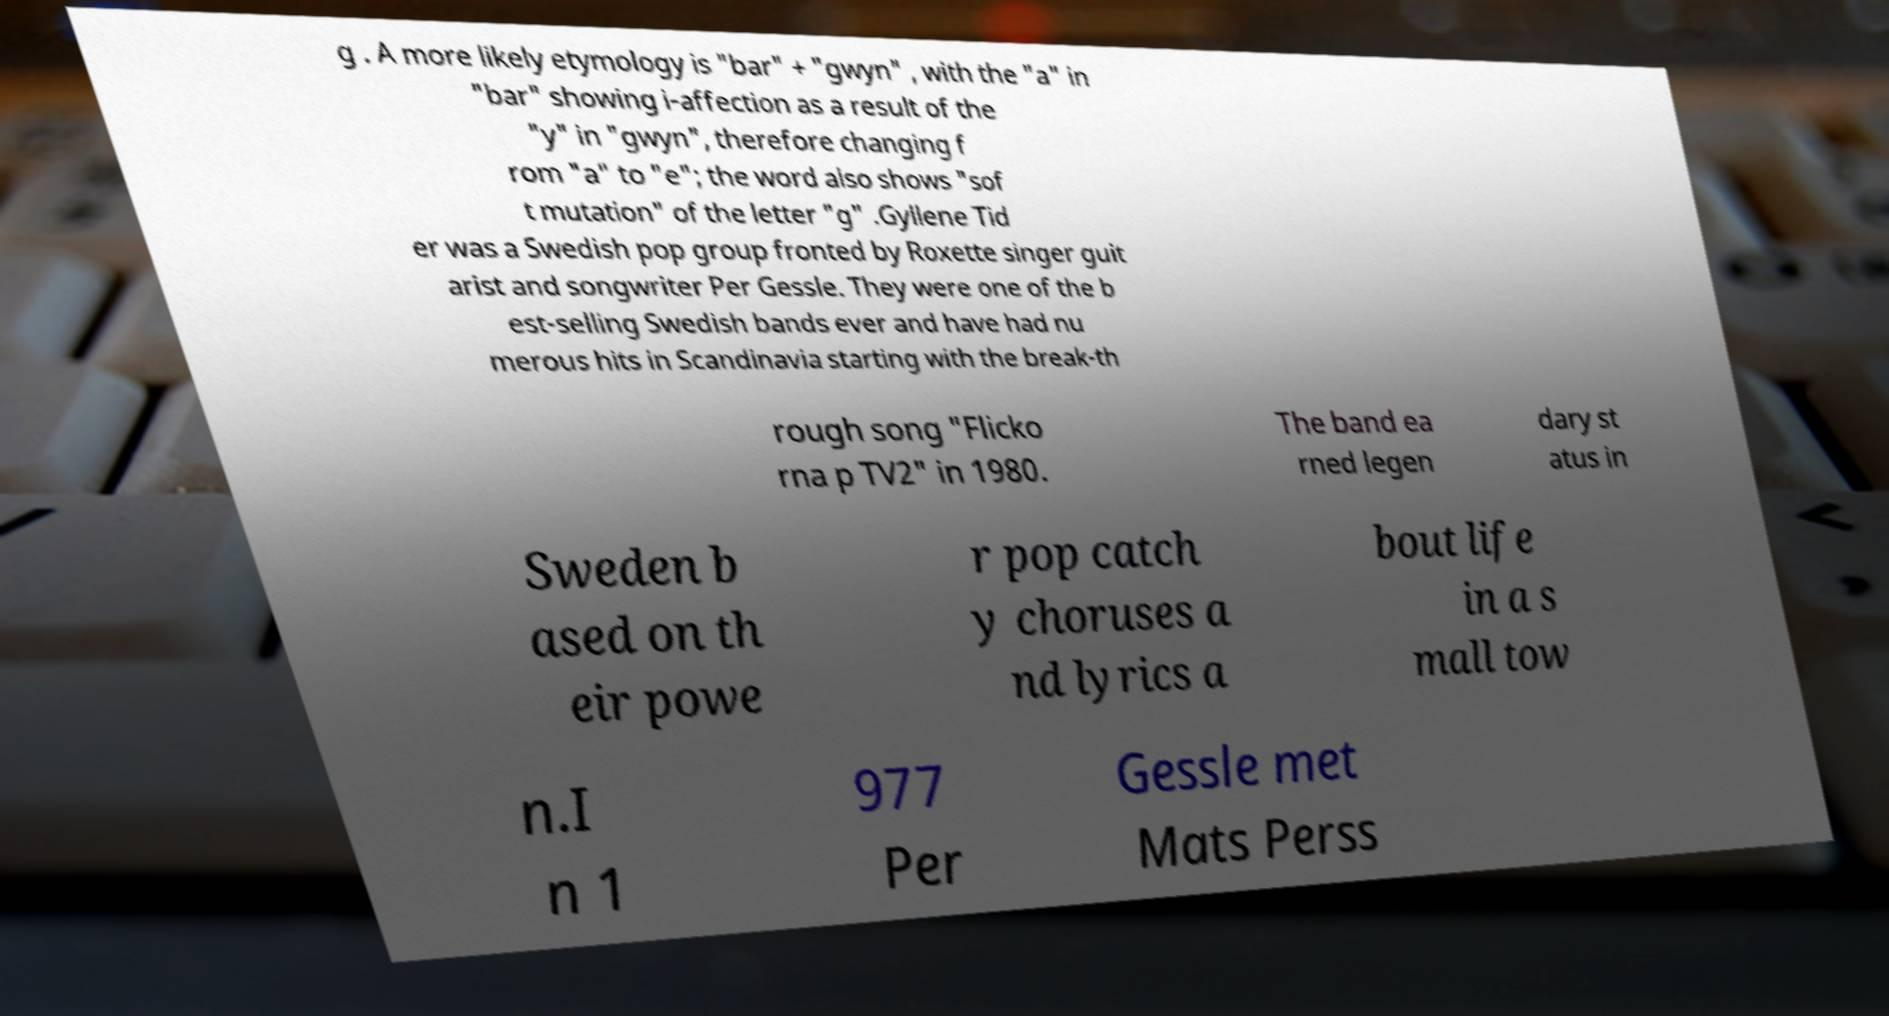What messages or text are displayed in this image? I need them in a readable, typed format. g . A more likely etymology is "bar" + "gwyn" , with the "a" in "bar" showing i-affection as a result of the "y" in "gwyn", therefore changing f rom "a" to "e"; the word also shows "sof t mutation" of the letter "g" .Gyllene Tid er was a Swedish pop group fronted by Roxette singer guit arist and songwriter Per Gessle. They were one of the b est-selling Swedish bands ever and have had nu merous hits in Scandinavia starting with the break-th rough song "Flicko rna p TV2" in 1980. The band ea rned legen dary st atus in Sweden b ased on th eir powe r pop catch y choruses a nd lyrics a bout life in a s mall tow n.I n 1 977 Per Gessle met Mats Perss 